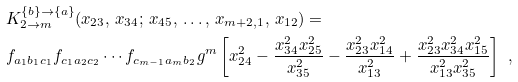<formula> <loc_0><loc_0><loc_500><loc_500>& K _ { 2 \rightarrow m } ^ { \{ b \} \rightarrow \{ a \} } ( x _ { 2 3 } , \, x _ { 3 4 } ; \, x _ { 4 5 } , \, \dots , \, x _ { m + 2 , 1 } , \, x _ { 1 2 } ) = \\ & f _ { a _ { 1 } b _ { 1 } c _ { 1 } } f _ { c _ { 1 } a _ { 2 } c _ { 2 } } \cdots f _ { c _ { m - 1 } a _ { m } b _ { 2 } } g ^ { m } \left [ x _ { 2 4 } ^ { 2 } - \frac { x _ { 3 4 } ^ { 2 } x _ { 2 5 } ^ { 2 } } { x _ { 3 5 } ^ { 2 } } - \frac { x _ { 2 3 } ^ { 2 } x _ { 1 4 } ^ { 2 } } { x _ { 1 3 } ^ { 2 } } + \frac { x _ { 2 3 } ^ { 2 } x _ { 3 4 } ^ { 2 } x _ { 1 5 } ^ { 2 } } { x _ { 1 3 } ^ { 2 } x _ { 3 5 } ^ { 2 } } \right ] \ ,</formula> 